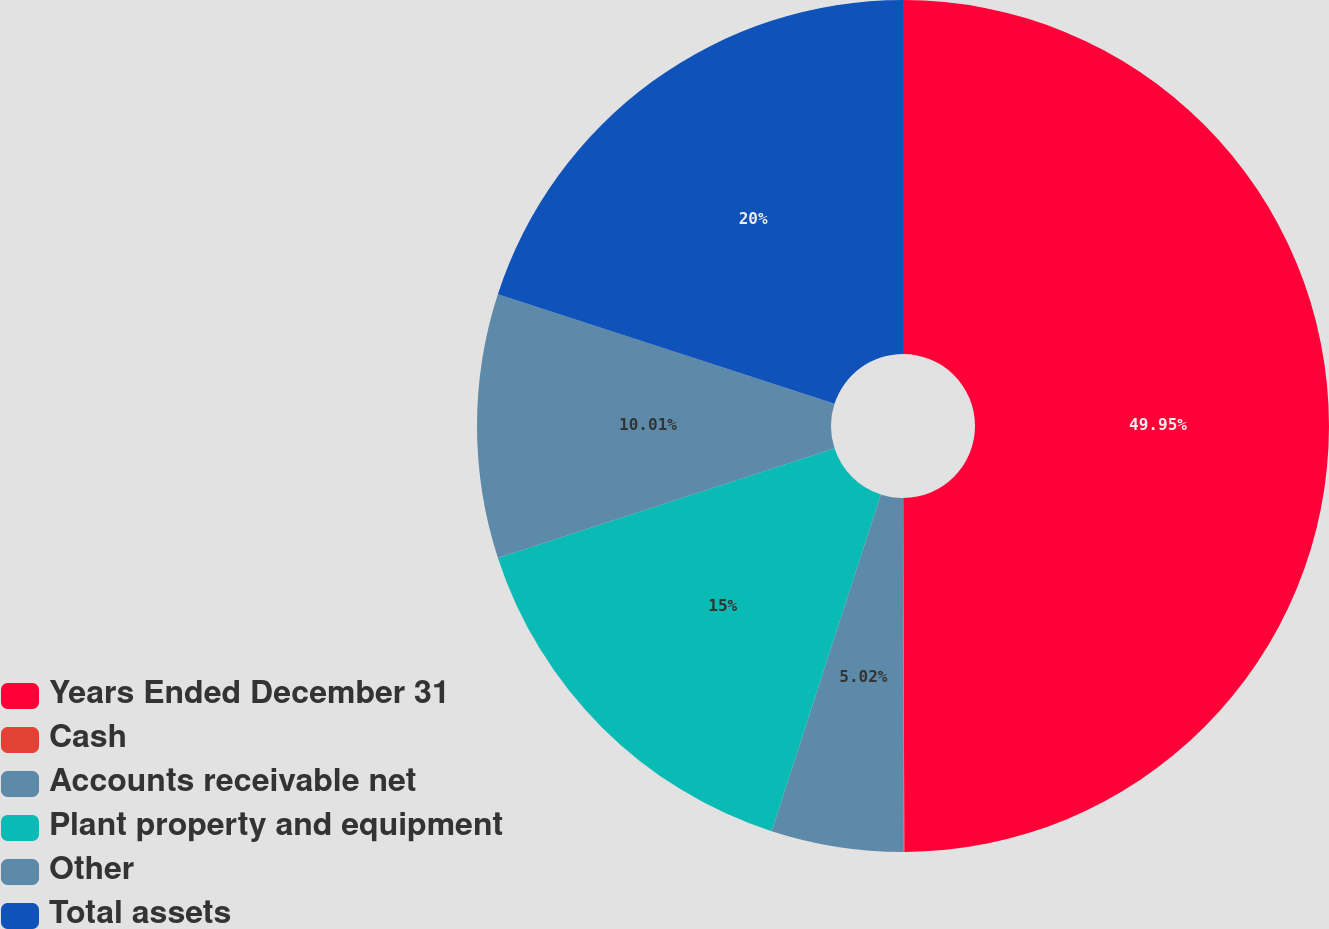Convert chart. <chart><loc_0><loc_0><loc_500><loc_500><pie_chart><fcel>Years Ended December 31<fcel>Cash<fcel>Accounts receivable net<fcel>Plant property and equipment<fcel>Other<fcel>Total assets<nl><fcel>49.95%<fcel>0.02%<fcel>5.02%<fcel>15.0%<fcel>10.01%<fcel>20.0%<nl></chart> 